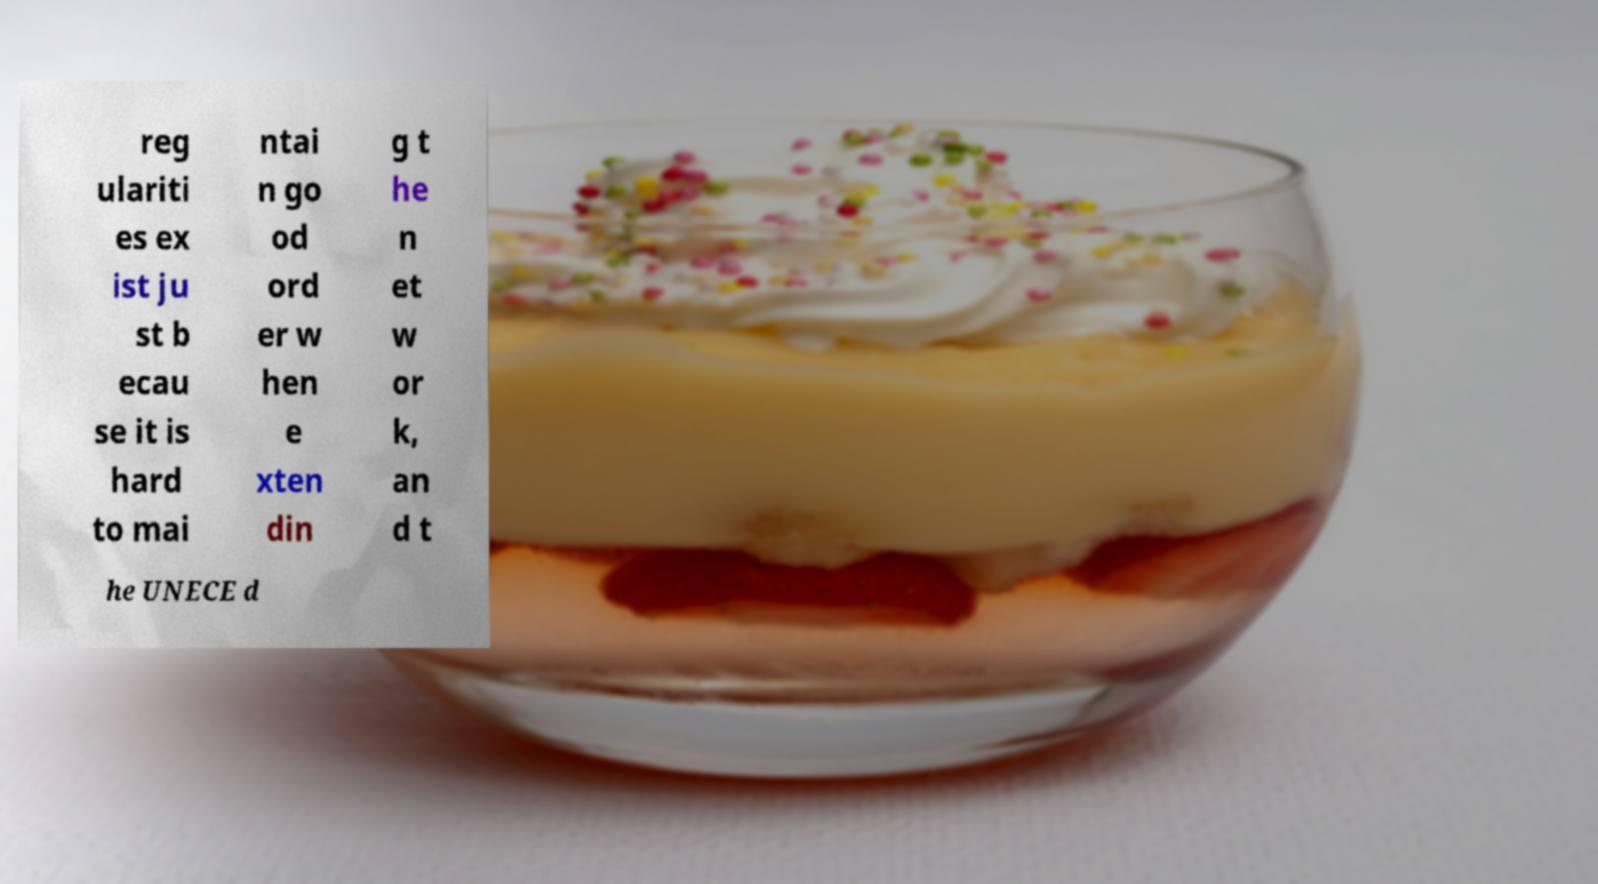I need the written content from this picture converted into text. Can you do that? reg ulariti es ex ist ju st b ecau se it is hard to mai ntai n go od ord er w hen e xten din g t he n et w or k, an d t he UNECE d 